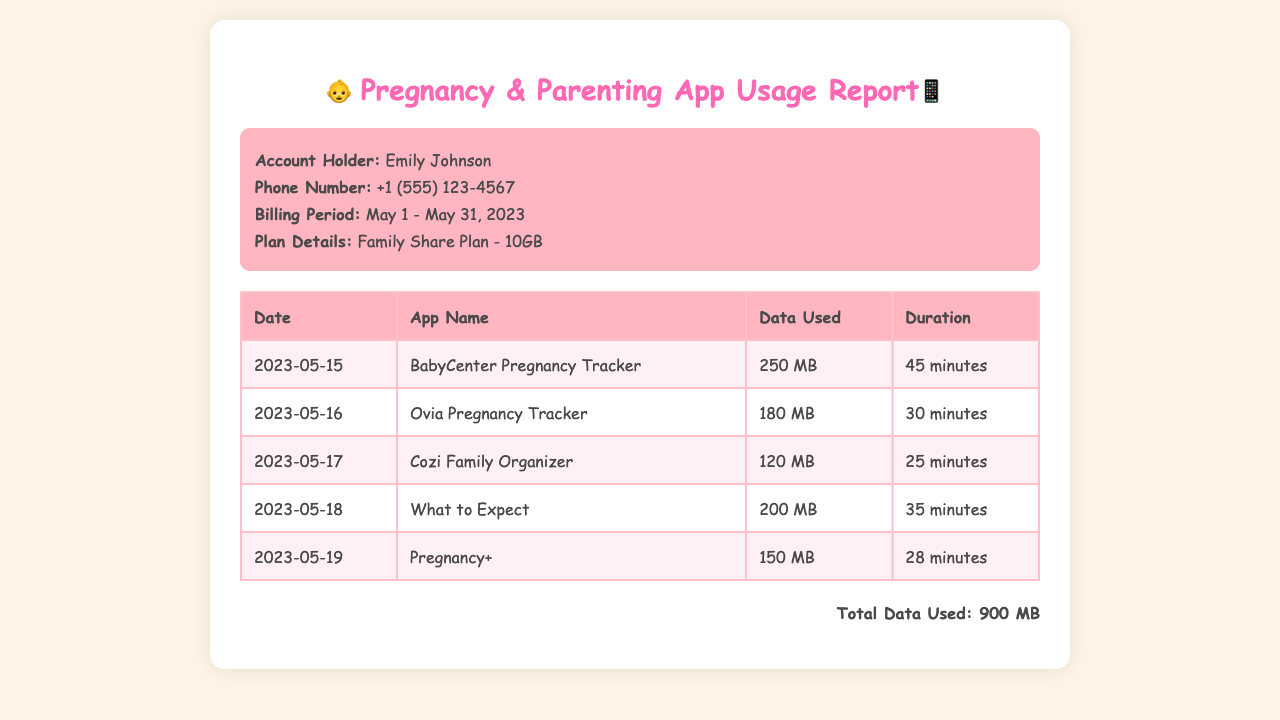What is the account holder's name? The account holder's name is specified in the account information section of the document.
Answer: Emily Johnson What is the billing period for this report? The billing period is listed within the account information area of the document.
Answer: May 1 - May 31, 2023 How much data was used by the Ovia Pregnancy Tracker? The data usage for each app is provided in the table under the "Data Used" column.
Answer: 180 MB Which app was used on May 18? The date each app was used corresponds to the entries in the table, providing specific app usage by date.
Answer: What to Expect What is the total data used during the billing period? The total data used is calculated from the data usage of each app listed in the table.
Answer: 900 MB How long was the usage duration for the Cozi Family Organizer? The usage duration is listed next to each corresponding app in the table.
Answer: 25 minutes What type of plan does the account holder have? The plan detail is mentioned in the account information section of the document.
Answer: Family Share Plan - 10GB What was the data usage for the BabyCenter Pregnancy Tracker? The specific data used by each app is detailed in the data usage table.
Answer: 250 MB When was the Pregnancy+ app used? The date of usage for each app can be found in the table, indicating when each app was accessed.
Answer: 2023-05-19 